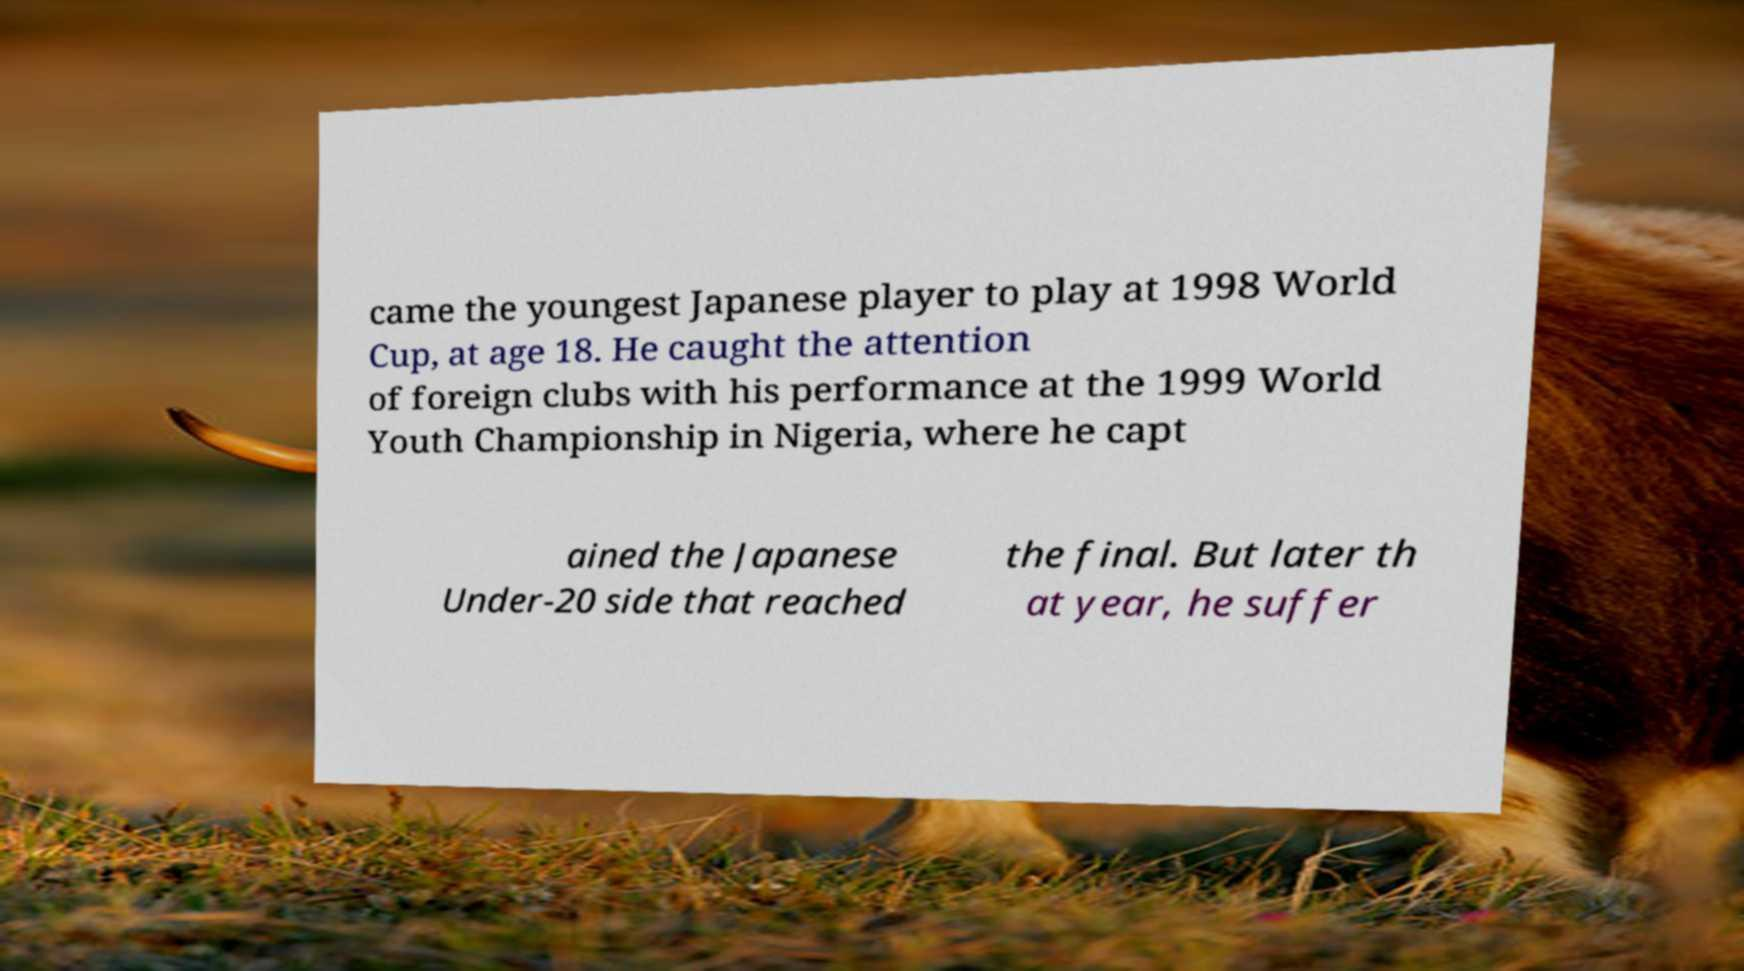There's text embedded in this image that I need extracted. Can you transcribe it verbatim? came the youngest Japanese player to play at 1998 World Cup, at age 18. He caught the attention of foreign clubs with his performance at the 1999 World Youth Championship in Nigeria, where he capt ained the Japanese Under-20 side that reached the final. But later th at year, he suffer 